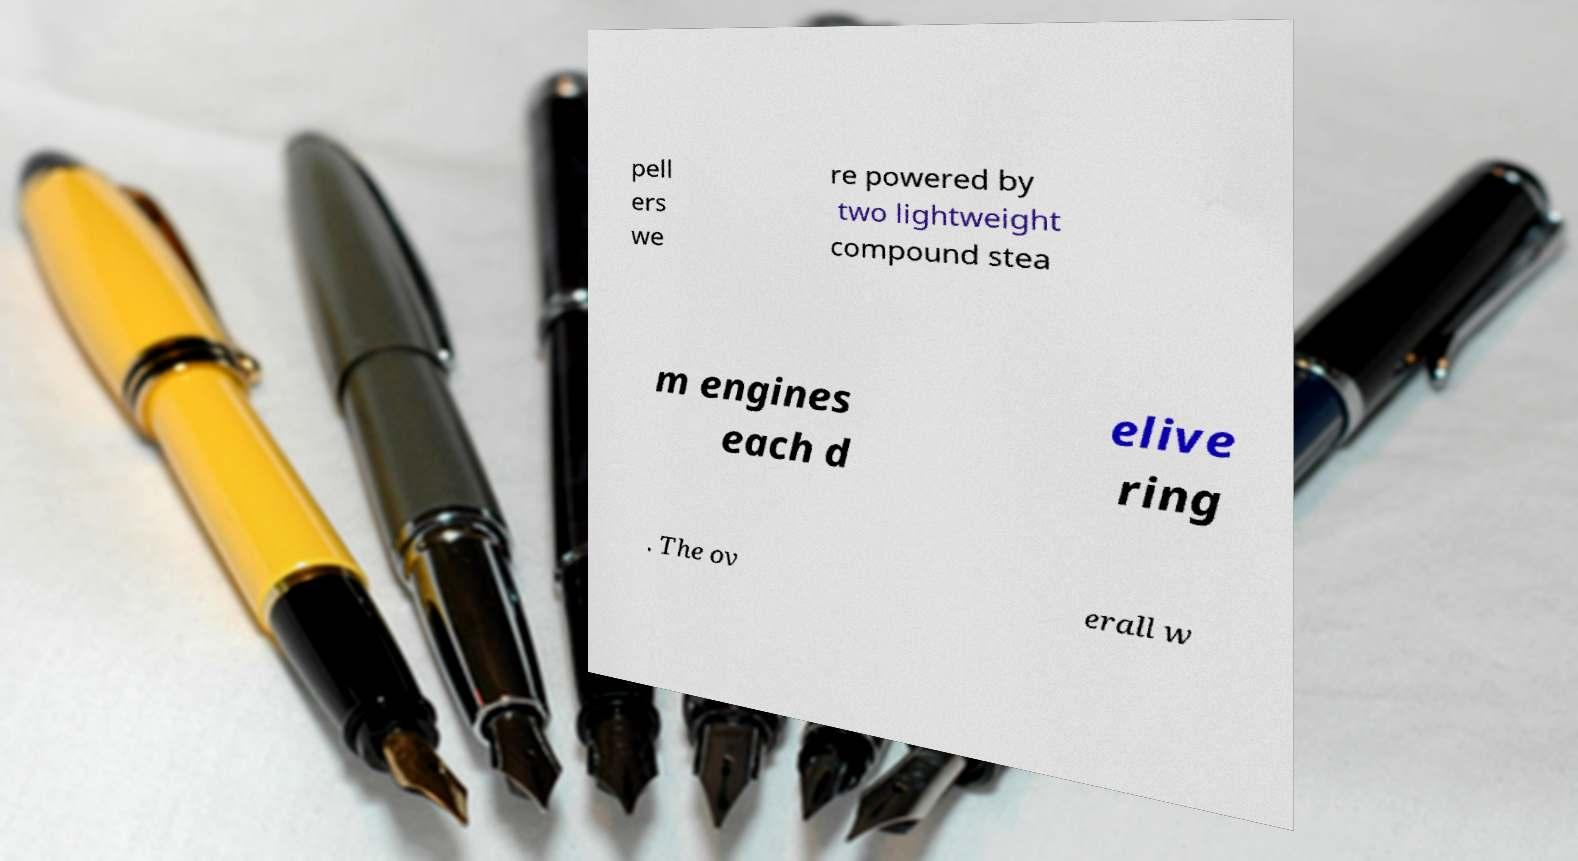Could you extract and type out the text from this image? pell ers we re powered by two lightweight compound stea m engines each d elive ring . The ov erall w 